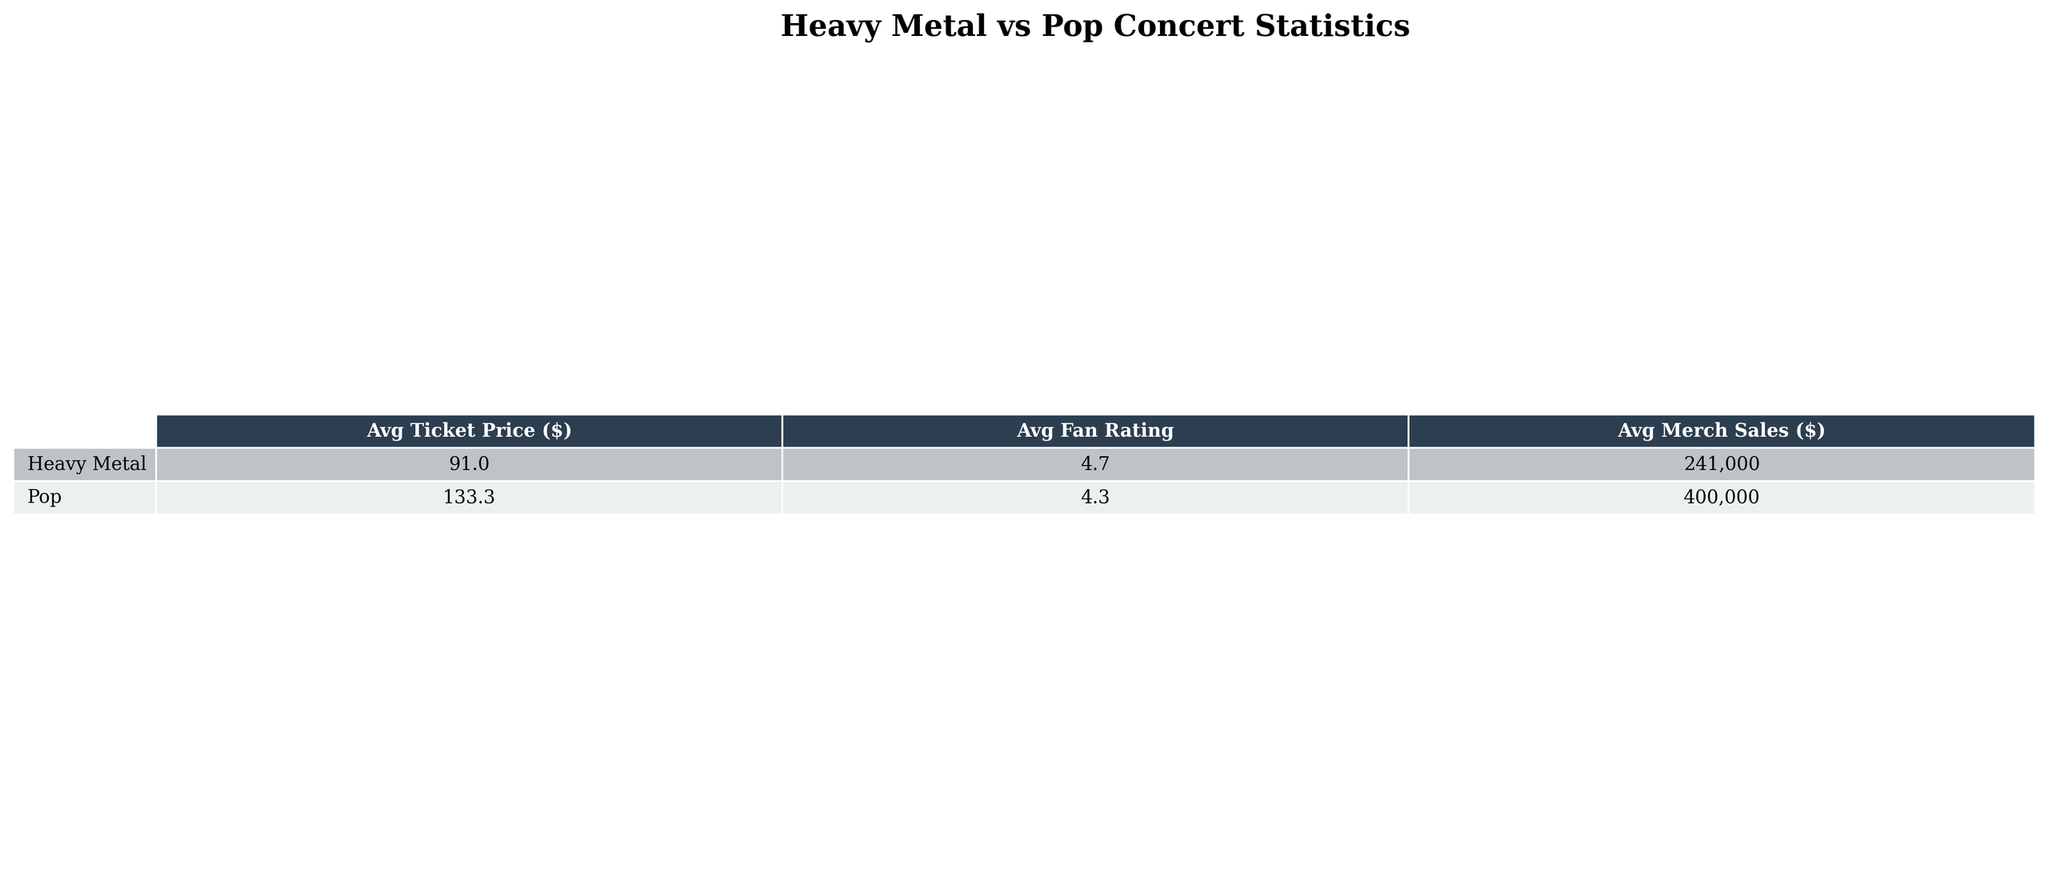What's the average ticket price for Heavy Metal concerts? For Heavy Metal concerts, the average ticket prices are $89.50, $112.75, $95.25, $75.00, and $82.50. To find the average, we add these values: $89.50 + $112.75 + $95.25 + $75.00 + $82.50 = $455.00. Then, we divide by the number of concerts (5): $455.00 / 5 = $91.00.
Answer: $91.00 What is the fan rating of Taylor Swift's concert? The table indicates that Taylor Swift's fan rating is listed as 4.5.
Answer: 4.5 Which genre has the highest average merch sales? The average merch sales for Heavy Metal concerts are calculated as follows: $250,000 + $300,000 + $275,000 + $200,000 + $180,000 = $1,205,000, and averaged over 5 concerts gives $241,000. For Pop, we calculate: $500,000 + $450,000 + $400,000 + $350,000 + $300,000 = $2,000,000, averaged over 5 concerts gives $400,000. Comparing the two averages, $400,000 > $241,000. Thus, Pop has higher average merch sales.
Answer: Pop What is the difference in average ticket price between Heavy Metal and Pop concerts? The average ticket price for Heavy Metal is $91.00, while for Pop, it is $132.25. To find the difference, we subtract $91.00 from $132.25: $132.25 - $91.00 = $41.25.
Answer: $41.25 Is the average fan rating for Heavy Metal concerts greater than 4.5? The average fan rating for Heavy Metal concerts is calculated as follows: (4.8 + 4.7 + 4.9 + 4.6 + 4.5) / 5 = 4.7. Since 4.7 is greater than 4.5, the statement is true.
Answer: Yes Which band had the lowest average ticket price? The average ticket prices are: Motley Crue ($89.50), Metallica ($112.75), Iron Maiden ($95.25), Slayer ($75.00), Megadeth ($82.50), Taylor Swift ($150.00), Justin Bieber ($125.50), Ariana Grande ($135.75), Lady Gaga ($145.25), Ed Sheeran ($110.00). The lowest price is $75.00, belonging to Slayer.
Answer: Slayer What is the average capacity of venues for Heavy Metal concerts? The venue capacities for Heavy Metal concerts are 15000, 20000, 18000, 12000, and 14000. Adding them together gives: 15000 + 20000 + 18000 + 12000 + 14000 = 79000. Dividing by 5 (the number of concerts) gives: 79000 / 5 = 15800.
Answer: 15800 How many concerts had a fan rating of 4.5 or above within the Heavy Metal genre? The Heavy Metal concerts with fan ratings are: 4.8, 4.7, 4.9, 4.6, and 4.5. All five ratings are 4.5 or higher, so the count is 5.
Answer: 5 Which pop artist had the highest average ticket price? The average ticket prices for Pop artists are: Taylor Swift ($150.00), Justin Bieber ($125.50), Ariana Grande ($135.75), Lady Gaga ($145.25), and Ed Sheeran ($110.00). Comparing these, Taylor Swift has the highest price at $150.00.
Answer: Taylor Swift What would be the total merch sales from all concerts in the Pop genre? The merch sales for Pop concerts are: $500,000 + $450,000 + $400,000 + $350,000 + $300,000 = $2,000,000.
Answer: $2,000,000 